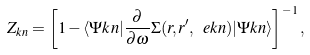<formula> <loc_0><loc_0><loc_500><loc_500>Z _ { { k } n } = \left [ 1 - \langle \Psi k n | \frac { \partial } { \partial \omega } \Sigma ( { r } , { r } ^ { \prime } , \ e k n ) | \Psi k n \rangle \right ] ^ { - 1 } ,</formula> 